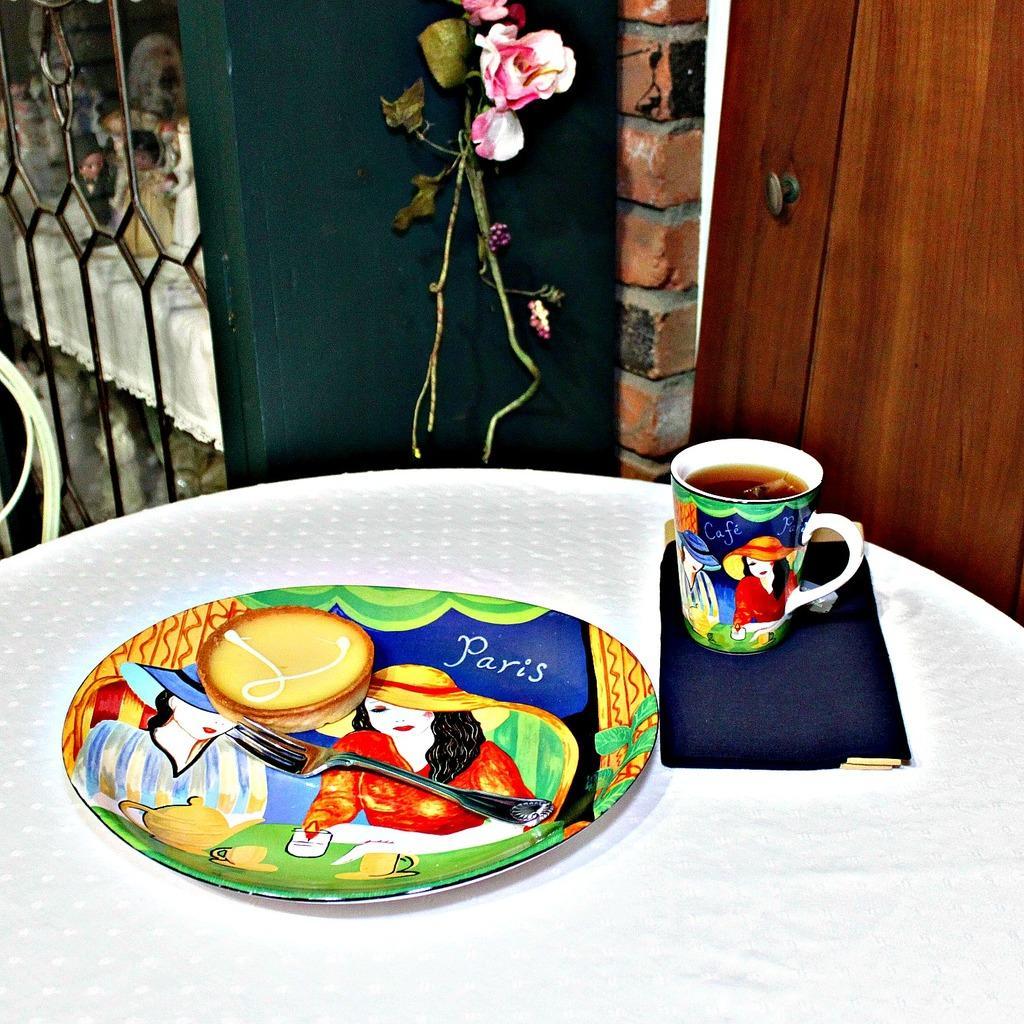Please provide a concise description of this image. Here we can see a plate with a cookie and fork on it and beside that there is a cup present on the table and at the top we can see rose flowers 